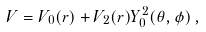Convert formula to latex. <formula><loc_0><loc_0><loc_500><loc_500>V = V _ { 0 } ( r ) + V _ { 2 } ( r ) Y _ { 0 } ^ { 2 } ( \theta , \phi ) \, ,</formula> 